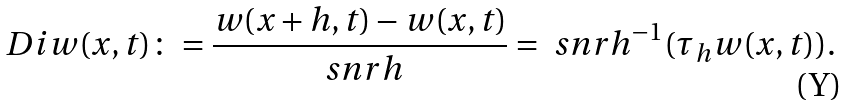<formula> <loc_0><loc_0><loc_500><loc_500>\ D i w ( x , t ) \colon = \frac { w ( x + h , t ) - w ( x , t ) } { \ s n r { h } } = \ s n r { h } ^ { - 1 } ( \tau _ { h } w ( x , t ) ) .</formula> 